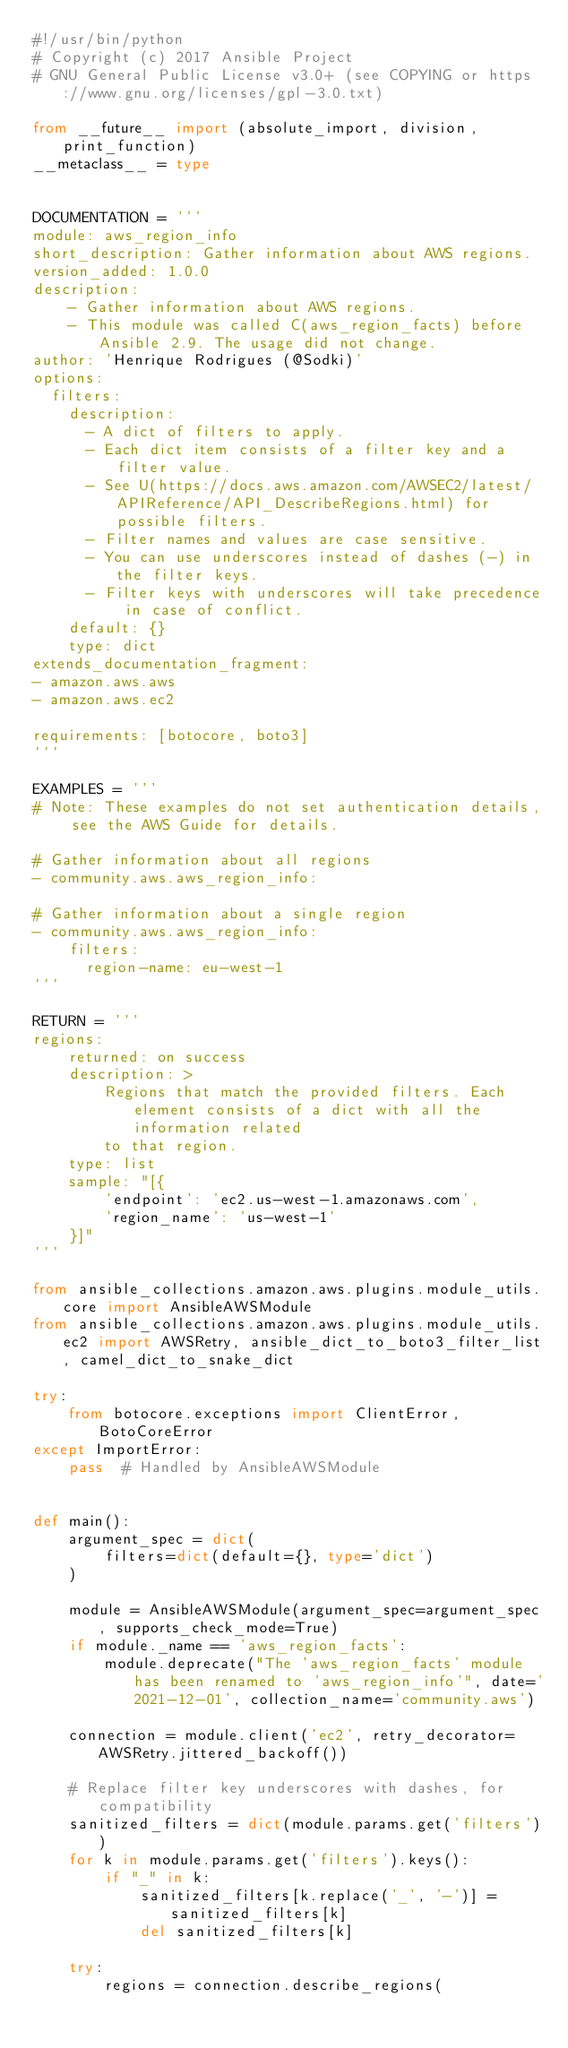<code> <loc_0><loc_0><loc_500><loc_500><_Python_>#!/usr/bin/python
# Copyright (c) 2017 Ansible Project
# GNU General Public License v3.0+ (see COPYING or https://www.gnu.org/licenses/gpl-3.0.txt)

from __future__ import (absolute_import, division, print_function)
__metaclass__ = type


DOCUMENTATION = '''
module: aws_region_info
short_description: Gather information about AWS regions.
version_added: 1.0.0
description:
    - Gather information about AWS regions.
    - This module was called C(aws_region_facts) before Ansible 2.9. The usage did not change.
author: 'Henrique Rodrigues (@Sodki)'
options:
  filters:
    description:
      - A dict of filters to apply.
      - Each dict item consists of a filter key and a filter value.
      - See U(https://docs.aws.amazon.com/AWSEC2/latest/APIReference/API_DescribeRegions.html) for possible filters.
      - Filter names and values are case sensitive.
      - You can use underscores instead of dashes (-) in the filter keys.
      - Filter keys with underscores will take precedence in case of conflict.
    default: {}
    type: dict
extends_documentation_fragment:
- amazon.aws.aws
- amazon.aws.ec2

requirements: [botocore, boto3]
'''

EXAMPLES = '''
# Note: These examples do not set authentication details, see the AWS Guide for details.

# Gather information about all regions
- community.aws.aws_region_info:

# Gather information about a single region
- community.aws.aws_region_info:
    filters:
      region-name: eu-west-1
'''

RETURN = '''
regions:
    returned: on success
    description: >
        Regions that match the provided filters. Each element consists of a dict with all the information related
        to that region.
    type: list
    sample: "[{
        'endpoint': 'ec2.us-west-1.amazonaws.com',
        'region_name': 'us-west-1'
    }]"
'''

from ansible_collections.amazon.aws.plugins.module_utils.core import AnsibleAWSModule
from ansible_collections.amazon.aws.plugins.module_utils.ec2 import AWSRetry, ansible_dict_to_boto3_filter_list, camel_dict_to_snake_dict

try:
    from botocore.exceptions import ClientError, BotoCoreError
except ImportError:
    pass  # Handled by AnsibleAWSModule


def main():
    argument_spec = dict(
        filters=dict(default={}, type='dict')
    )

    module = AnsibleAWSModule(argument_spec=argument_spec, supports_check_mode=True)
    if module._name == 'aws_region_facts':
        module.deprecate("The 'aws_region_facts' module has been renamed to 'aws_region_info'", date='2021-12-01', collection_name='community.aws')

    connection = module.client('ec2', retry_decorator=AWSRetry.jittered_backoff())

    # Replace filter key underscores with dashes, for compatibility
    sanitized_filters = dict(module.params.get('filters'))
    for k in module.params.get('filters').keys():
        if "_" in k:
            sanitized_filters[k.replace('_', '-')] = sanitized_filters[k]
            del sanitized_filters[k]

    try:
        regions = connection.describe_regions(</code> 